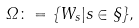<formula> <loc_0><loc_0><loc_500><loc_500>\Omega \colon = \{ W _ { s } | s \in \S \} ,</formula> 